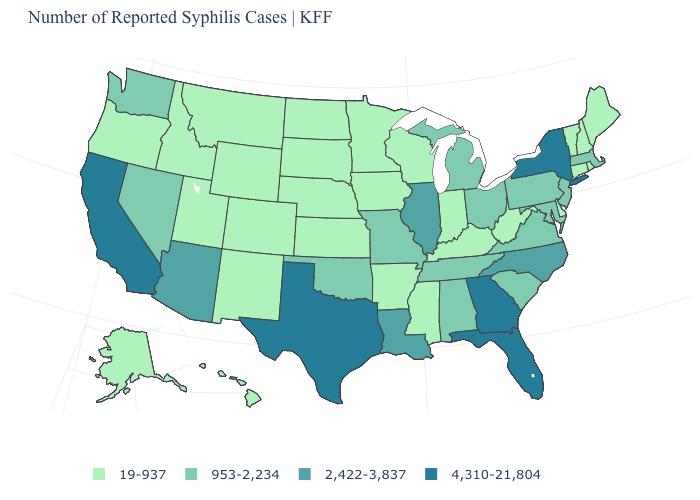Does the first symbol in the legend represent the smallest category?
Short answer required. Yes. What is the value of Delaware?
Concise answer only. 19-937. What is the value of Arizona?
Be succinct. 2,422-3,837. What is the value of Michigan?
Write a very short answer. 953-2,234. Name the states that have a value in the range 19-937?
Quick response, please. Alaska, Arkansas, Colorado, Connecticut, Delaware, Hawaii, Idaho, Indiana, Iowa, Kansas, Kentucky, Maine, Minnesota, Mississippi, Montana, Nebraska, New Hampshire, New Mexico, North Dakota, Oregon, Rhode Island, South Dakota, Utah, Vermont, West Virginia, Wisconsin, Wyoming. What is the value of Hawaii?
Concise answer only. 19-937. What is the highest value in states that border Montana?
Quick response, please. 19-937. What is the value of Pennsylvania?
Write a very short answer. 953-2,234. What is the value of Kentucky?
Keep it brief. 19-937. What is the lowest value in the West?
Give a very brief answer. 19-937. What is the value of California?
Short answer required. 4,310-21,804. Name the states that have a value in the range 953-2,234?
Quick response, please. Alabama, Maryland, Massachusetts, Michigan, Missouri, Nevada, New Jersey, Ohio, Oklahoma, Pennsylvania, South Carolina, Tennessee, Virginia, Washington. Which states have the highest value in the USA?
Quick response, please. California, Florida, Georgia, New York, Texas. Is the legend a continuous bar?
Be succinct. No. Does the first symbol in the legend represent the smallest category?
Concise answer only. Yes. 